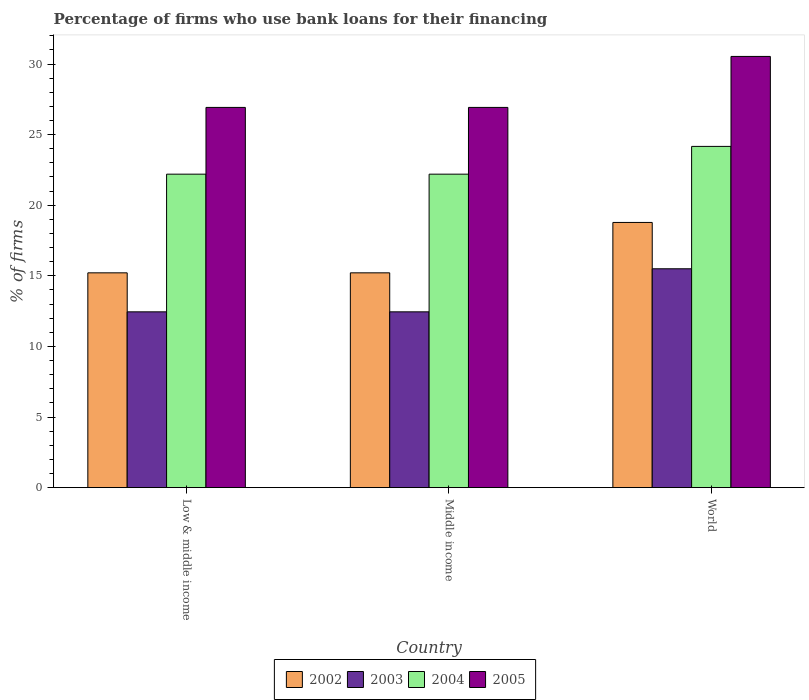Are the number of bars on each tick of the X-axis equal?
Provide a succinct answer. Yes. How many bars are there on the 1st tick from the left?
Keep it short and to the point. 4. What is the label of the 3rd group of bars from the left?
Your answer should be compact. World. What is the percentage of firms who use bank loans for their financing in 2003 in Middle income?
Give a very brief answer. 12.45. Across all countries, what is the maximum percentage of firms who use bank loans for their financing in 2002?
Your answer should be very brief. 18.78. Across all countries, what is the minimum percentage of firms who use bank loans for their financing in 2005?
Keep it short and to the point. 26.93. What is the total percentage of firms who use bank loans for their financing in 2004 in the graph?
Give a very brief answer. 68.57. What is the difference between the percentage of firms who use bank loans for their financing in 2003 in Low & middle income and that in World?
Keep it short and to the point. -3.05. What is the difference between the percentage of firms who use bank loans for their financing in 2005 in Middle income and the percentage of firms who use bank loans for their financing in 2003 in World?
Give a very brief answer. 11.43. What is the average percentage of firms who use bank loans for their financing in 2004 per country?
Your answer should be very brief. 22.86. What is the difference between the percentage of firms who use bank loans for their financing of/in 2004 and percentage of firms who use bank loans for their financing of/in 2003 in Middle income?
Keep it short and to the point. 9.75. What is the ratio of the percentage of firms who use bank loans for their financing in 2002 in Low & middle income to that in World?
Your answer should be very brief. 0.81. Is the difference between the percentage of firms who use bank loans for their financing in 2004 in Low & middle income and Middle income greater than the difference between the percentage of firms who use bank loans for their financing in 2003 in Low & middle income and Middle income?
Give a very brief answer. No. What is the difference between the highest and the second highest percentage of firms who use bank loans for their financing in 2004?
Make the answer very short. 1.97. What is the difference between the highest and the lowest percentage of firms who use bank loans for their financing in 2002?
Offer a terse response. 3.57. Is the sum of the percentage of firms who use bank loans for their financing in 2003 in Low & middle income and World greater than the maximum percentage of firms who use bank loans for their financing in 2002 across all countries?
Give a very brief answer. Yes. What does the 1st bar from the left in World represents?
Provide a succinct answer. 2002. Is it the case that in every country, the sum of the percentage of firms who use bank loans for their financing in 2002 and percentage of firms who use bank loans for their financing in 2004 is greater than the percentage of firms who use bank loans for their financing in 2003?
Offer a very short reply. Yes. How many bars are there?
Your response must be concise. 12. Are all the bars in the graph horizontal?
Provide a short and direct response. No. How many countries are there in the graph?
Give a very brief answer. 3. Where does the legend appear in the graph?
Your answer should be compact. Bottom center. How many legend labels are there?
Provide a succinct answer. 4. How are the legend labels stacked?
Ensure brevity in your answer.  Horizontal. What is the title of the graph?
Your answer should be very brief. Percentage of firms who use bank loans for their financing. What is the label or title of the X-axis?
Make the answer very short. Country. What is the label or title of the Y-axis?
Give a very brief answer. % of firms. What is the % of firms in 2002 in Low & middle income?
Offer a very short reply. 15.21. What is the % of firms of 2003 in Low & middle income?
Your answer should be compact. 12.45. What is the % of firms of 2005 in Low & middle income?
Give a very brief answer. 26.93. What is the % of firms in 2002 in Middle income?
Your answer should be very brief. 15.21. What is the % of firms of 2003 in Middle income?
Provide a short and direct response. 12.45. What is the % of firms of 2004 in Middle income?
Provide a succinct answer. 22.2. What is the % of firms in 2005 in Middle income?
Provide a succinct answer. 26.93. What is the % of firms of 2002 in World?
Your answer should be compact. 18.78. What is the % of firms in 2003 in World?
Your answer should be compact. 15.5. What is the % of firms of 2004 in World?
Provide a succinct answer. 24.17. What is the % of firms of 2005 in World?
Provide a short and direct response. 30.54. Across all countries, what is the maximum % of firms of 2002?
Ensure brevity in your answer.  18.78. Across all countries, what is the maximum % of firms in 2003?
Make the answer very short. 15.5. Across all countries, what is the maximum % of firms of 2004?
Give a very brief answer. 24.17. Across all countries, what is the maximum % of firms of 2005?
Provide a succinct answer. 30.54. Across all countries, what is the minimum % of firms of 2002?
Give a very brief answer. 15.21. Across all countries, what is the minimum % of firms of 2003?
Keep it short and to the point. 12.45. Across all countries, what is the minimum % of firms in 2004?
Your answer should be compact. 22.2. Across all countries, what is the minimum % of firms of 2005?
Provide a succinct answer. 26.93. What is the total % of firms in 2002 in the graph?
Ensure brevity in your answer.  49.21. What is the total % of firms of 2003 in the graph?
Ensure brevity in your answer.  40.4. What is the total % of firms of 2004 in the graph?
Your answer should be compact. 68.57. What is the total % of firms of 2005 in the graph?
Provide a short and direct response. 84.39. What is the difference between the % of firms in 2005 in Low & middle income and that in Middle income?
Make the answer very short. 0. What is the difference between the % of firms of 2002 in Low & middle income and that in World?
Offer a terse response. -3.57. What is the difference between the % of firms in 2003 in Low & middle income and that in World?
Make the answer very short. -3.05. What is the difference between the % of firms in 2004 in Low & middle income and that in World?
Your answer should be compact. -1.97. What is the difference between the % of firms in 2005 in Low & middle income and that in World?
Keep it short and to the point. -3.61. What is the difference between the % of firms in 2002 in Middle income and that in World?
Make the answer very short. -3.57. What is the difference between the % of firms in 2003 in Middle income and that in World?
Provide a short and direct response. -3.05. What is the difference between the % of firms in 2004 in Middle income and that in World?
Make the answer very short. -1.97. What is the difference between the % of firms of 2005 in Middle income and that in World?
Provide a short and direct response. -3.61. What is the difference between the % of firms of 2002 in Low & middle income and the % of firms of 2003 in Middle income?
Provide a succinct answer. 2.76. What is the difference between the % of firms in 2002 in Low & middle income and the % of firms in 2004 in Middle income?
Your answer should be very brief. -6.99. What is the difference between the % of firms of 2002 in Low & middle income and the % of firms of 2005 in Middle income?
Provide a succinct answer. -11.72. What is the difference between the % of firms of 2003 in Low & middle income and the % of firms of 2004 in Middle income?
Ensure brevity in your answer.  -9.75. What is the difference between the % of firms of 2003 in Low & middle income and the % of firms of 2005 in Middle income?
Offer a terse response. -14.48. What is the difference between the % of firms of 2004 in Low & middle income and the % of firms of 2005 in Middle income?
Keep it short and to the point. -4.73. What is the difference between the % of firms of 2002 in Low & middle income and the % of firms of 2003 in World?
Provide a short and direct response. -0.29. What is the difference between the % of firms in 2002 in Low & middle income and the % of firms in 2004 in World?
Provide a short and direct response. -8.95. What is the difference between the % of firms of 2002 in Low & middle income and the % of firms of 2005 in World?
Keep it short and to the point. -15.33. What is the difference between the % of firms in 2003 in Low & middle income and the % of firms in 2004 in World?
Give a very brief answer. -11.72. What is the difference between the % of firms in 2003 in Low & middle income and the % of firms in 2005 in World?
Keep it short and to the point. -18.09. What is the difference between the % of firms in 2004 in Low & middle income and the % of firms in 2005 in World?
Provide a short and direct response. -8.34. What is the difference between the % of firms of 2002 in Middle income and the % of firms of 2003 in World?
Keep it short and to the point. -0.29. What is the difference between the % of firms in 2002 in Middle income and the % of firms in 2004 in World?
Provide a succinct answer. -8.95. What is the difference between the % of firms in 2002 in Middle income and the % of firms in 2005 in World?
Your answer should be compact. -15.33. What is the difference between the % of firms in 2003 in Middle income and the % of firms in 2004 in World?
Offer a terse response. -11.72. What is the difference between the % of firms of 2003 in Middle income and the % of firms of 2005 in World?
Make the answer very short. -18.09. What is the difference between the % of firms of 2004 in Middle income and the % of firms of 2005 in World?
Make the answer very short. -8.34. What is the average % of firms in 2002 per country?
Offer a very short reply. 16.4. What is the average % of firms of 2003 per country?
Keep it short and to the point. 13.47. What is the average % of firms in 2004 per country?
Ensure brevity in your answer.  22.86. What is the average % of firms of 2005 per country?
Provide a succinct answer. 28.13. What is the difference between the % of firms in 2002 and % of firms in 2003 in Low & middle income?
Give a very brief answer. 2.76. What is the difference between the % of firms of 2002 and % of firms of 2004 in Low & middle income?
Your answer should be very brief. -6.99. What is the difference between the % of firms in 2002 and % of firms in 2005 in Low & middle income?
Provide a short and direct response. -11.72. What is the difference between the % of firms in 2003 and % of firms in 2004 in Low & middle income?
Give a very brief answer. -9.75. What is the difference between the % of firms of 2003 and % of firms of 2005 in Low & middle income?
Offer a very short reply. -14.48. What is the difference between the % of firms in 2004 and % of firms in 2005 in Low & middle income?
Provide a succinct answer. -4.73. What is the difference between the % of firms in 2002 and % of firms in 2003 in Middle income?
Provide a succinct answer. 2.76. What is the difference between the % of firms of 2002 and % of firms of 2004 in Middle income?
Keep it short and to the point. -6.99. What is the difference between the % of firms of 2002 and % of firms of 2005 in Middle income?
Provide a succinct answer. -11.72. What is the difference between the % of firms of 2003 and % of firms of 2004 in Middle income?
Your response must be concise. -9.75. What is the difference between the % of firms of 2003 and % of firms of 2005 in Middle income?
Your answer should be compact. -14.48. What is the difference between the % of firms in 2004 and % of firms in 2005 in Middle income?
Provide a short and direct response. -4.73. What is the difference between the % of firms of 2002 and % of firms of 2003 in World?
Keep it short and to the point. 3.28. What is the difference between the % of firms of 2002 and % of firms of 2004 in World?
Provide a succinct answer. -5.39. What is the difference between the % of firms of 2002 and % of firms of 2005 in World?
Your answer should be compact. -11.76. What is the difference between the % of firms in 2003 and % of firms in 2004 in World?
Make the answer very short. -8.67. What is the difference between the % of firms of 2003 and % of firms of 2005 in World?
Provide a short and direct response. -15.04. What is the difference between the % of firms of 2004 and % of firms of 2005 in World?
Your response must be concise. -6.37. What is the ratio of the % of firms in 2003 in Low & middle income to that in Middle income?
Your answer should be very brief. 1. What is the ratio of the % of firms of 2004 in Low & middle income to that in Middle income?
Your answer should be compact. 1. What is the ratio of the % of firms in 2002 in Low & middle income to that in World?
Ensure brevity in your answer.  0.81. What is the ratio of the % of firms of 2003 in Low & middle income to that in World?
Make the answer very short. 0.8. What is the ratio of the % of firms of 2004 in Low & middle income to that in World?
Your answer should be very brief. 0.92. What is the ratio of the % of firms in 2005 in Low & middle income to that in World?
Offer a terse response. 0.88. What is the ratio of the % of firms in 2002 in Middle income to that in World?
Ensure brevity in your answer.  0.81. What is the ratio of the % of firms of 2003 in Middle income to that in World?
Offer a very short reply. 0.8. What is the ratio of the % of firms of 2004 in Middle income to that in World?
Keep it short and to the point. 0.92. What is the ratio of the % of firms of 2005 in Middle income to that in World?
Provide a short and direct response. 0.88. What is the difference between the highest and the second highest % of firms of 2002?
Offer a terse response. 3.57. What is the difference between the highest and the second highest % of firms of 2003?
Your answer should be very brief. 3.05. What is the difference between the highest and the second highest % of firms in 2004?
Give a very brief answer. 1.97. What is the difference between the highest and the second highest % of firms of 2005?
Offer a very short reply. 3.61. What is the difference between the highest and the lowest % of firms of 2002?
Your answer should be compact. 3.57. What is the difference between the highest and the lowest % of firms of 2003?
Offer a very short reply. 3.05. What is the difference between the highest and the lowest % of firms in 2004?
Your answer should be compact. 1.97. What is the difference between the highest and the lowest % of firms in 2005?
Provide a short and direct response. 3.61. 